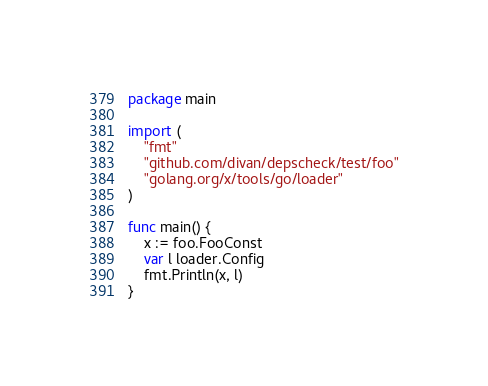<code> <loc_0><loc_0><loc_500><loc_500><_Go_>package main

import (
	"fmt"
	"github.com/divan/depscheck/test/foo"
	"golang.org/x/tools/go/loader"
)

func main() {
	x := foo.FooConst
	var l loader.Config
	fmt.Println(x, l)
}
</code> 